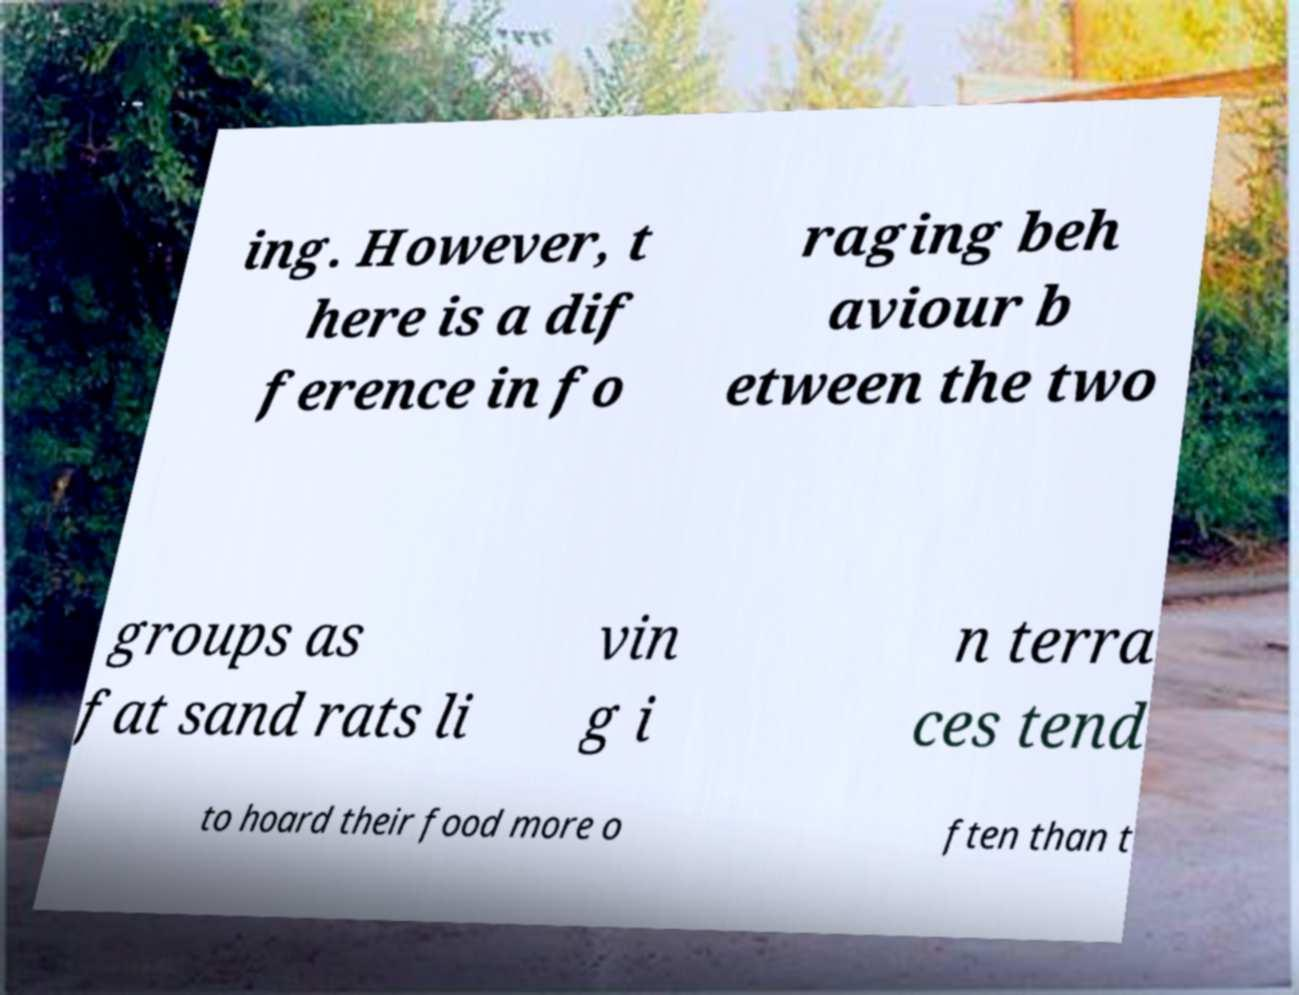Please identify and transcribe the text found in this image. ing. However, t here is a dif ference in fo raging beh aviour b etween the two groups as fat sand rats li vin g i n terra ces tend to hoard their food more o ften than t 